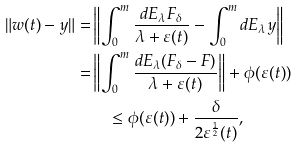Convert formula to latex. <formula><loc_0><loc_0><loc_500><loc_500>\| w ( t ) - y \| = & \left \| \int ^ { m } _ { 0 } \frac { d E _ { \lambda } F _ { \delta } } { \lambda + \varepsilon ( t ) } - \int ^ { m } _ { 0 } d E _ { \lambda } y \right \| \\ = & \left \| \int ^ { m } _ { 0 } \frac { d E _ { \lambda } ( F _ { \delta } - F ) } { \lambda + \varepsilon ( t ) } \right \| + \phi ( \varepsilon ( t ) ) \\ & \quad \leq \phi ( \varepsilon ( t ) ) + \frac { \delta } { 2 \varepsilon ^ { \frac { 1 } { 2 } } ( t ) } ,</formula> 